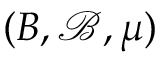<formula> <loc_0><loc_0><loc_500><loc_500>( B , { \mathcal { B } } , \mu )</formula> 